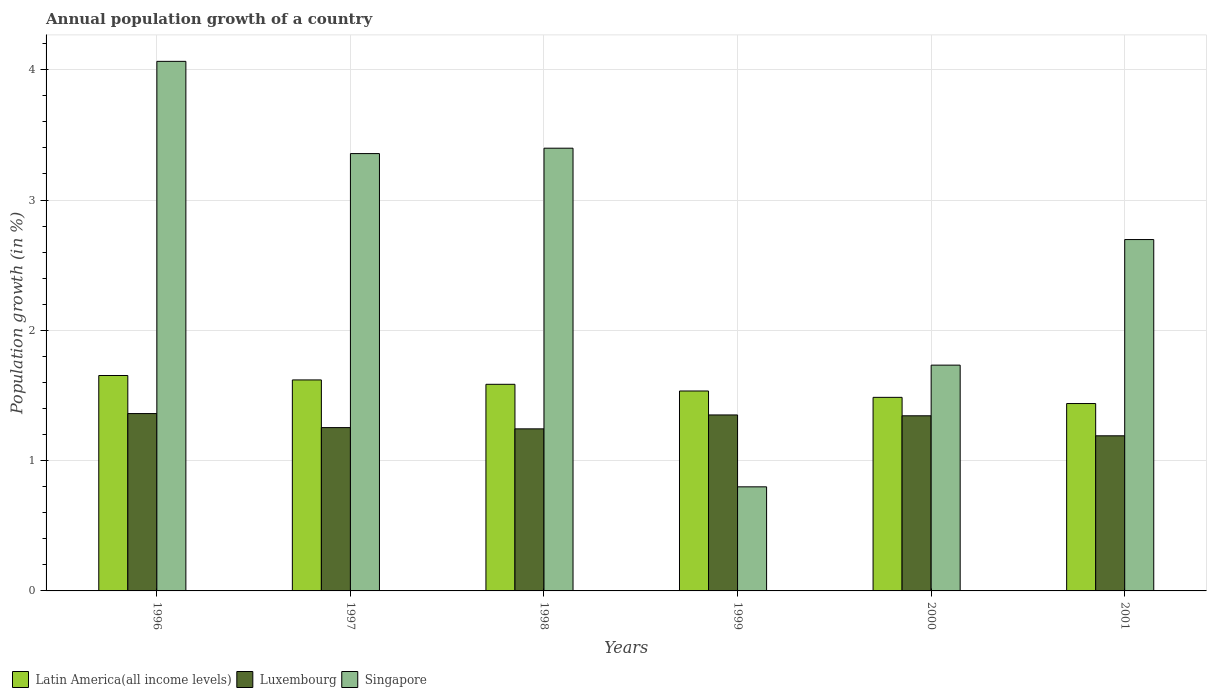How many different coloured bars are there?
Give a very brief answer. 3. How many groups of bars are there?
Give a very brief answer. 6. How many bars are there on the 5th tick from the left?
Give a very brief answer. 3. What is the label of the 5th group of bars from the left?
Ensure brevity in your answer.  2000. What is the annual population growth in Singapore in 1998?
Your answer should be compact. 3.4. Across all years, what is the maximum annual population growth in Luxembourg?
Your answer should be very brief. 1.36. Across all years, what is the minimum annual population growth in Latin America(all income levels)?
Ensure brevity in your answer.  1.44. In which year was the annual population growth in Singapore maximum?
Your response must be concise. 1996. What is the total annual population growth in Luxembourg in the graph?
Offer a very short reply. 7.74. What is the difference between the annual population growth in Latin America(all income levels) in 1997 and that in 2001?
Offer a very short reply. 0.18. What is the difference between the annual population growth in Singapore in 1997 and the annual population growth in Luxembourg in 1996?
Your response must be concise. 2. What is the average annual population growth in Singapore per year?
Make the answer very short. 2.67. In the year 1996, what is the difference between the annual population growth in Luxembourg and annual population growth in Latin America(all income levels)?
Provide a short and direct response. -0.29. In how many years, is the annual population growth in Luxembourg greater than 1.4 %?
Offer a very short reply. 0. What is the ratio of the annual population growth in Singapore in 1996 to that in 1997?
Offer a terse response. 1.21. Is the annual population growth in Latin America(all income levels) in 1998 less than that in 2000?
Keep it short and to the point. No. Is the difference between the annual population growth in Luxembourg in 1998 and 2000 greater than the difference between the annual population growth in Latin America(all income levels) in 1998 and 2000?
Your answer should be compact. No. What is the difference between the highest and the second highest annual population growth in Singapore?
Offer a very short reply. 0.67. What is the difference between the highest and the lowest annual population growth in Singapore?
Make the answer very short. 3.27. What does the 3rd bar from the left in 1998 represents?
Provide a short and direct response. Singapore. What does the 2nd bar from the right in 1999 represents?
Offer a very short reply. Luxembourg. How many bars are there?
Your response must be concise. 18. Are all the bars in the graph horizontal?
Give a very brief answer. No. Does the graph contain grids?
Provide a succinct answer. Yes. How are the legend labels stacked?
Your response must be concise. Horizontal. What is the title of the graph?
Your answer should be compact. Annual population growth of a country. Does "Palau" appear as one of the legend labels in the graph?
Your answer should be compact. No. What is the label or title of the Y-axis?
Make the answer very short. Population growth (in %). What is the Population growth (in %) of Latin America(all income levels) in 1996?
Ensure brevity in your answer.  1.65. What is the Population growth (in %) in Luxembourg in 1996?
Provide a succinct answer. 1.36. What is the Population growth (in %) of Singapore in 1996?
Your answer should be very brief. 4.06. What is the Population growth (in %) of Latin America(all income levels) in 1997?
Keep it short and to the point. 1.62. What is the Population growth (in %) of Luxembourg in 1997?
Offer a very short reply. 1.25. What is the Population growth (in %) of Singapore in 1997?
Your answer should be compact. 3.36. What is the Population growth (in %) of Latin America(all income levels) in 1998?
Give a very brief answer. 1.59. What is the Population growth (in %) of Luxembourg in 1998?
Provide a short and direct response. 1.24. What is the Population growth (in %) of Singapore in 1998?
Your response must be concise. 3.4. What is the Population growth (in %) of Latin America(all income levels) in 1999?
Your answer should be very brief. 1.53. What is the Population growth (in %) of Luxembourg in 1999?
Your response must be concise. 1.35. What is the Population growth (in %) of Singapore in 1999?
Ensure brevity in your answer.  0.8. What is the Population growth (in %) in Latin America(all income levels) in 2000?
Keep it short and to the point. 1.49. What is the Population growth (in %) of Luxembourg in 2000?
Offer a very short reply. 1.34. What is the Population growth (in %) of Singapore in 2000?
Keep it short and to the point. 1.73. What is the Population growth (in %) in Latin America(all income levels) in 2001?
Give a very brief answer. 1.44. What is the Population growth (in %) of Luxembourg in 2001?
Provide a short and direct response. 1.19. What is the Population growth (in %) of Singapore in 2001?
Your answer should be very brief. 2.7. Across all years, what is the maximum Population growth (in %) of Latin America(all income levels)?
Keep it short and to the point. 1.65. Across all years, what is the maximum Population growth (in %) of Luxembourg?
Give a very brief answer. 1.36. Across all years, what is the maximum Population growth (in %) of Singapore?
Give a very brief answer. 4.06. Across all years, what is the minimum Population growth (in %) in Latin America(all income levels)?
Give a very brief answer. 1.44. Across all years, what is the minimum Population growth (in %) of Luxembourg?
Offer a terse response. 1.19. Across all years, what is the minimum Population growth (in %) of Singapore?
Keep it short and to the point. 0.8. What is the total Population growth (in %) of Latin America(all income levels) in the graph?
Keep it short and to the point. 9.32. What is the total Population growth (in %) of Luxembourg in the graph?
Your answer should be compact. 7.74. What is the total Population growth (in %) of Singapore in the graph?
Your answer should be very brief. 16.05. What is the difference between the Population growth (in %) in Latin America(all income levels) in 1996 and that in 1997?
Offer a terse response. 0.03. What is the difference between the Population growth (in %) in Luxembourg in 1996 and that in 1997?
Provide a short and direct response. 0.11. What is the difference between the Population growth (in %) of Singapore in 1996 and that in 1997?
Ensure brevity in your answer.  0.71. What is the difference between the Population growth (in %) in Latin America(all income levels) in 1996 and that in 1998?
Your answer should be very brief. 0.07. What is the difference between the Population growth (in %) in Luxembourg in 1996 and that in 1998?
Offer a terse response. 0.12. What is the difference between the Population growth (in %) in Singapore in 1996 and that in 1998?
Offer a terse response. 0.67. What is the difference between the Population growth (in %) in Latin America(all income levels) in 1996 and that in 1999?
Make the answer very short. 0.12. What is the difference between the Population growth (in %) in Luxembourg in 1996 and that in 1999?
Provide a short and direct response. 0.01. What is the difference between the Population growth (in %) of Singapore in 1996 and that in 1999?
Provide a short and direct response. 3.27. What is the difference between the Population growth (in %) of Latin America(all income levels) in 1996 and that in 2000?
Your response must be concise. 0.17. What is the difference between the Population growth (in %) of Luxembourg in 1996 and that in 2000?
Ensure brevity in your answer.  0.02. What is the difference between the Population growth (in %) in Singapore in 1996 and that in 2000?
Your answer should be compact. 2.33. What is the difference between the Population growth (in %) of Latin America(all income levels) in 1996 and that in 2001?
Provide a succinct answer. 0.22. What is the difference between the Population growth (in %) of Luxembourg in 1996 and that in 2001?
Ensure brevity in your answer.  0.17. What is the difference between the Population growth (in %) of Singapore in 1996 and that in 2001?
Your response must be concise. 1.37. What is the difference between the Population growth (in %) in Latin America(all income levels) in 1997 and that in 1998?
Provide a short and direct response. 0.03. What is the difference between the Population growth (in %) in Luxembourg in 1997 and that in 1998?
Provide a short and direct response. 0.01. What is the difference between the Population growth (in %) of Singapore in 1997 and that in 1998?
Offer a very short reply. -0.04. What is the difference between the Population growth (in %) of Latin America(all income levels) in 1997 and that in 1999?
Ensure brevity in your answer.  0.08. What is the difference between the Population growth (in %) of Luxembourg in 1997 and that in 1999?
Keep it short and to the point. -0.1. What is the difference between the Population growth (in %) of Singapore in 1997 and that in 1999?
Provide a short and direct response. 2.56. What is the difference between the Population growth (in %) in Latin America(all income levels) in 1997 and that in 2000?
Give a very brief answer. 0.13. What is the difference between the Population growth (in %) in Luxembourg in 1997 and that in 2000?
Offer a terse response. -0.09. What is the difference between the Population growth (in %) of Singapore in 1997 and that in 2000?
Ensure brevity in your answer.  1.62. What is the difference between the Population growth (in %) in Latin America(all income levels) in 1997 and that in 2001?
Provide a short and direct response. 0.18. What is the difference between the Population growth (in %) in Luxembourg in 1997 and that in 2001?
Give a very brief answer. 0.06. What is the difference between the Population growth (in %) in Singapore in 1997 and that in 2001?
Your answer should be compact. 0.66. What is the difference between the Population growth (in %) in Latin America(all income levels) in 1998 and that in 1999?
Your response must be concise. 0.05. What is the difference between the Population growth (in %) of Luxembourg in 1998 and that in 1999?
Offer a very short reply. -0.11. What is the difference between the Population growth (in %) of Singapore in 1998 and that in 1999?
Give a very brief answer. 2.6. What is the difference between the Population growth (in %) of Latin America(all income levels) in 1998 and that in 2000?
Your response must be concise. 0.1. What is the difference between the Population growth (in %) of Luxembourg in 1998 and that in 2000?
Provide a short and direct response. -0.1. What is the difference between the Population growth (in %) in Singapore in 1998 and that in 2000?
Provide a short and direct response. 1.66. What is the difference between the Population growth (in %) in Latin America(all income levels) in 1998 and that in 2001?
Make the answer very short. 0.15. What is the difference between the Population growth (in %) of Luxembourg in 1998 and that in 2001?
Your answer should be compact. 0.05. What is the difference between the Population growth (in %) of Singapore in 1998 and that in 2001?
Offer a very short reply. 0.7. What is the difference between the Population growth (in %) in Latin America(all income levels) in 1999 and that in 2000?
Your answer should be very brief. 0.05. What is the difference between the Population growth (in %) of Luxembourg in 1999 and that in 2000?
Provide a short and direct response. 0.01. What is the difference between the Population growth (in %) in Singapore in 1999 and that in 2000?
Your answer should be compact. -0.93. What is the difference between the Population growth (in %) of Latin America(all income levels) in 1999 and that in 2001?
Keep it short and to the point. 0.1. What is the difference between the Population growth (in %) in Luxembourg in 1999 and that in 2001?
Provide a succinct answer. 0.16. What is the difference between the Population growth (in %) of Singapore in 1999 and that in 2001?
Provide a succinct answer. -1.9. What is the difference between the Population growth (in %) of Latin America(all income levels) in 2000 and that in 2001?
Your answer should be compact. 0.05. What is the difference between the Population growth (in %) of Luxembourg in 2000 and that in 2001?
Ensure brevity in your answer.  0.15. What is the difference between the Population growth (in %) of Singapore in 2000 and that in 2001?
Your answer should be very brief. -0.96. What is the difference between the Population growth (in %) of Latin America(all income levels) in 1996 and the Population growth (in %) of Luxembourg in 1997?
Give a very brief answer. 0.4. What is the difference between the Population growth (in %) in Latin America(all income levels) in 1996 and the Population growth (in %) in Singapore in 1997?
Your response must be concise. -1.7. What is the difference between the Population growth (in %) of Luxembourg in 1996 and the Population growth (in %) of Singapore in 1997?
Ensure brevity in your answer.  -2. What is the difference between the Population growth (in %) of Latin America(all income levels) in 1996 and the Population growth (in %) of Luxembourg in 1998?
Offer a very short reply. 0.41. What is the difference between the Population growth (in %) of Latin America(all income levels) in 1996 and the Population growth (in %) of Singapore in 1998?
Keep it short and to the point. -1.74. What is the difference between the Population growth (in %) in Luxembourg in 1996 and the Population growth (in %) in Singapore in 1998?
Ensure brevity in your answer.  -2.04. What is the difference between the Population growth (in %) in Latin America(all income levels) in 1996 and the Population growth (in %) in Luxembourg in 1999?
Offer a terse response. 0.3. What is the difference between the Population growth (in %) in Latin America(all income levels) in 1996 and the Population growth (in %) in Singapore in 1999?
Keep it short and to the point. 0.85. What is the difference between the Population growth (in %) in Luxembourg in 1996 and the Population growth (in %) in Singapore in 1999?
Give a very brief answer. 0.56. What is the difference between the Population growth (in %) of Latin America(all income levels) in 1996 and the Population growth (in %) of Luxembourg in 2000?
Your response must be concise. 0.31. What is the difference between the Population growth (in %) of Latin America(all income levels) in 1996 and the Population growth (in %) of Singapore in 2000?
Provide a succinct answer. -0.08. What is the difference between the Population growth (in %) in Luxembourg in 1996 and the Population growth (in %) in Singapore in 2000?
Ensure brevity in your answer.  -0.37. What is the difference between the Population growth (in %) in Latin America(all income levels) in 1996 and the Population growth (in %) in Luxembourg in 2001?
Provide a succinct answer. 0.46. What is the difference between the Population growth (in %) of Latin America(all income levels) in 1996 and the Population growth (in %) of Singapore in 2001?
Your answer should be very brief. -1.04. What is the difference between the Population growth (in %) of Luxembourg in 1996 and the Population growth (in %) of Singapore in 2001?
Provide a succinct answer. -1.34. What is the difference between the Population growth (in %) in Latin America(all income levels) in 1997 and the Population growth (in %) in Luxembourg in 1998?
Provide a succinct answer. 0.38. What is the difference between the Population growth (in %) in Latin America(all income levels) in 1997 and the Population growth (in %) in Singapore in 1998?
Your answer should be very brief. -1.78. What is the difference between the Population growth (in %) of Luxembourg in 1997 and the Population growth (in %) of Singapore in 1998?
Your response must be concise. -2.14. What is the difference between the Population growth (in %) of Latin America(all income levels) in 1997 and the Population growth (in %) of Luxembourg in 1999?
Provide a short and direct response. 0.27. What is the difference between the Population growth (in %) of Latin America(all income levels) in 1997 and the Population growth (in %) of Singapore in 1999?
Offer a terse response. 0.82. What is the difference between the Population growth (in %) of Luxembourg in 1997 and the Population growth (in %) of Singapore in 1999?
Your answer should be very brief. 0.45. What is the difference between the Population growth (in %) in Latin America(all income levels) in 1997 and the Population growth (in %) in Luxembourg in 2000?
Provide a short and direct response. 0.28. What is the difference between the Population growth (in %) in Latin America(all income levels) in 1997 and the Population growth (in %) in Singapore in 2000?
Offer a very short reply. -0.11. What is the difference between the Population growth (in %) in Luxembourg in 1997 and the Population growth (in %) in Singapore in 2000?
Offer a very short reply. -0.48. What is the difference between the Population growth (in %) of Latin America(all income levels) in 1997 and the Population growth (in %) of Luxembourg in 2001?
Make the answer very short. 0.43. What is the difference between the Population growth (in %) in Latin America(all income levels) in 1997 and the Population growth (in %) in Singapore in 2001?
Provide a succinct answer. -1.08. What is the difference between the Population growth (in %) in Luxembourg in 1997 and the Population growth (in %) in Singapore in 2001?
Your response must be concise. -1.44. What is the difference between the Population growth (in %) of Latin America(all income levels) in 1998 and the Population growth (in %) of Luxembourg in 1999?
Your answer should be very brief. 0.24. What is the difference between the Population growth (in %) in Latin America(all income levels) in 1998 and the Population growth (in %) in Singapore in 1999?
Provide a short and direct response. 0.79. What is the difference between the Population growth (in %) of Luxembourg in 1998 and the Population growth (in %) of Singapore in 1999?
Your answer should be compact. 0.45. What is the difference between the Population growth (in %) in Latin America(all income levels) in 1998 and the Population growth (in %) in Luxembourg in 2000?
Keep it short and to the point. 0.24. What is the difference between the Population growth (in %) of Latin America(all income levels) in 1998 and the Population growth (in %) of Singapore in 2000?
Make the answer very short. -0.15. What is the difference between the Population growth (in %) in Luxembourg in 1998 and the Population growth (in %) in Singapore in 2000?
Make the answer very short. -0.49. What is the difference between the Population growth (in %) of Latin America(all income levels) in 1998 and the Population growth (in %) of Luxembourg in 2001?
Give a very brief answer. 0.4. What is the difference between the Population growth (in %) in Latin America(all income levels) in 1998 and the Population growth (in %) in Singapore in 2001?
Provide a short and direct response. -1.11. What is the difference between the Population growth (in %) of Luxembourg in 1998 and the Population growth (in %) of Singapore in 2001?
Ensure brevity in your answer.  -1.45. What is the difference between the Population growth (in %) of Latin America(all income levels) in 1999 and the Population growth (in %) of Luxembourg in 2000?
Provide a short and direct response. 0.19. What is the difference between the Population growth (in %) in Latin America(all income levels) in 1999 and the Population growth (in %) in Singapore in 2000?
Offer a terse response. -0.2. What is the difference between the Population growth (in %) in Luxembourg in 1999 and the Population growth (in %) in Singapore in 2000?
Ensure brevity in your answer.  -0.38. What is the difference between the Population growth (in %) in Latin America(all income levels) in 1999 and the Population growth (in %) in Luxembourg in 2001?
Keep it short and to the point. 0.34. What is the difference between the Population growth (in %) in Latin America(all income levels) in 1999 and the Population growth (in %) in Singapore in 2001?
Offer a very short reply. -1.16. What is the difference between the Population growth (in %) of Luxembourg in 1999 and the Population growth (in %) of Singapore in 2001?
Your answer should be compact. -1.35. What is the difference between the Population growth (in %) of Latin America(all income levels) in 2000 and the Population growth (in %) of Luxembourg in 2001?
Provide a short and direct response. 0.3. What is the difference between the Population growth (in %) in Latin America(all income levels) in 2000 and the Population growth (in %) in Singapore in 2001?
Offer a terse response. -1.21. What is the difference between the Population growth (in %) of Luxembourg in 2000 and the Population growth (in %) of Singapore in 2001?
Offer a terse response. -1.35. What is the average Population growth (in %) of Latin America(all income levels) per year?
Keep it short and to the point. 1.55. What is the average Population growth (in %) of Luxembourg per year?
Your answer should be compact. 1.29. What is the average Population growth (in %) in Singapore per year?
Provide a short and direct response. 2.67. In the year 1996, what is the difference between the Population growth (in %) in Latin America(all income levels) and Population growth (in %) in Luxembourg?
Give a very brief answer. 0.29. In the year 1996, what is the difference between the Population growth (in %) of Latin America(all income levels) and Population growth (in %) of Singapore?
Keep it short and to the point. -2.41. In the year 1996, what is the difference between the Population growth (in %) of Luxembourg and Population growth (in %) of Singapore?
Your answer should be very brief. -2.7. In the year 1997, what is the difference between the Population growth (in %) in Latin America(all income levels) and Population growth (in %) in Luxembourg?
Your answer should be very brief. 0.37. In the year 1997, what is the difference between the Population growth (in %) of Latin America(all income levels) and Population growth (in %) of Singapore?
Your response must be concise. -1.74. In the year 1997, what is the difference between the Population growth (in %) in Luxembourg and Population growth (in %) in Singapore?
Keep it short and to the point. -2.1. In the year 1998, what is the difference between the Population growth (in %) of Latin America(all income levels) and Population growth (in %) of Luxembourg?
Your response must be concise. 0.34. In the year 1998, what is the difference between the Population growth (in %) of Latin America(all income levels) and Population growth (in %) of Singapore?
Your answer should be very brief. -1.81. In the year 1998, what is the difference between the Population growth (in %) in Luxembourg and Population growth (in %) in Singapore?
Offer a very short reply. -2.15. In the year 1999, what is the difference between the Population growth (in %) of Latin America(all income levels) and Population growth (in %) of Luxembourg?
Provide a short and direct response. 0.18. In the year 1999, what is the difference between the Population growth (in %) in Latin America(all income levels) and Population growth (in %) in Singapore?
Make the answer very short. 0.74. In the year 1999, what is the difference between the Population growth (in %) of Luxembourg and Population growth (in %) of Singapore?
Your response must be concise. 0.55. In the year 2000, what is the difference between the Population growth (in %) of Latin America(all income levels) and Population growth (in %) of Luxembourg?
Give a very brief answer. 0.14. In the year 2000, what is the difference between the Population growth (in %) in Latin America(all income levels) and Population growth (in %) in Singapore?
Offer a terse response. -0.25. In the year 2000, what is the difference between the Population growth (in %) in Luxembourg and Population growth (in %) in Singapore?
Your answer should be compact. -0.39. In the year 2001, what is the difference between the Population growth (in %) in Latin America(all income levels) and Population growth (in %) in Luxembourg?
Your answer should be very brief. 0.25. In the year 2001, what is the difference between the Population growth (in %) in Latin America(all income levels) and Population growth (in %) in Singapore?
Your answer should be compact. -1.26. In the year 2001, what is the difference between the Population growth (in %) in Luxembourg and Population growth (in %) in Singapore?
Offer a terse response. -1.51. What is the ratio of the Population growth (in %) in Latin America(all income levels) in 1996 to that in 1997?
Give a very brief answer. 1.02. What is the ratio of the Population growth (in %) of Luxembourg in 1996 to that in 1997?
Ensure brevity in your answer.  1.09. What is the ratio of the Population growth (in %) in Singapore in 1996 to that in 1997?
Offer a very short reply. 1.21. What is the ratio of the Population growth (in %) of Latin America(all income levels) in 1996 to that in 1998?
Provide a succinct answer. 1.04. What is the ratio of the Population growth (in %) of Luxembourg in 1996 to that in 1998?
Offer a very short reply. 1.09. What is the ratio of the Population growth (in %) in Singapore in 1996 to that in 1998?
Your answer should be compact. 1.2. What is the ratio of the Population growth (in %) in Latin America(all income levels) in 1996 to that in 1999?
Keep it short and to the point. 1.08. What is the ratio of the Population growth (in %) in Singapore in 1996 to that in 1999?
Provide a succinct answer. 5.09. What is the ratio of the Population growth (in %) of Latin America(all income levels) in 1996 to that in 2000?
Your response must be concise. 1.11. What is the ratio of the Population growth (in %) in Luxembourg in 1996 to that in 2000?
Give a very brief answer. 1.01. What is the ratio of the Population growth (in %) of Singapore in 1996 to that in 2000?
Your answer should be compact. 2.35. What is the ratio of the Population growth (in %) of Latin America(all income levels) in 1996 to that in 2001?
Your response must be concise. 1.15. What is the ratio of the Population growth (in %) of Luxembourg in 1996 to that in 2001?
Your answer should be very brief. 1.14. What is the ratio of the Population growth (in %) in Singapore in 1996 to that in 2001?
Your answer should be very brief. 1.51. What is the ratio of the Population growth (in %) in Latin America(all income levels) in 1997 to that in 1998?
Give a very brief answer. 1.02. What is the ratio of the Population growth (in %) in Luxembourg in 1997 to that in 1998?
Provide a succinct answer. 1.01. What is the ratio of the Population growth (in %) in Singapore in 1997 to that in 1998?
Ensure brevity in your answer.  0.99. What is the ratio of the Population growth (in %) in Latin America(all income levels) in 1997 to that in 1999?
Your answer should be compact. 1.06. What is the ratio of the Population growth (in %) in Luxembourg in 1997 to that in 1999?
Your response must be concise. 0.93. What is the ratio of the Population growth (in %) in Singapore in 1997 to that in 1999?
Make the answer very short. 4.2. What is the ratio of the Population growth (in %) in Latin America(all income levels) in 1997 to that in 2000?
Offer a very short reply. 1.09. What is the ratio of the Population growth (in %) of Luxembourg in 1997 to that in 2000?
Keep it short and to the point. 0.93. What is the ratio of the Population growth (in %) of Singapore in 1997 to that in 2000?
Offer a terse response. 1.94. What is the ratio of the Population growth (in %) in Latin America(all income levels) in 1997 to that in 2001?
Offer a very short reply. 1.13. What is the ratio of the Population growth (in %) of Luxembourg in 1997 to that in 2001?
Provide a short and direct response. 1.05. What is the ratio of the Population growth (in %) of Singapore in 1997 to that in 2001?
Ensure brevity in your answer.  1.24. What is the ratio of the Population growth (in %) in Latin America(all income levels) in 1998 to that in 1999?
Provide a succinct answer. 1.03. What is the ratio of the Population growth (in %) in Luxembourg in 1998 to that in 1999?
Your answer should be compact. 0.92. What is the ratio of the Population growth (in %) in Singapore in 1998 to that in 1999?
Provide a short and direct response. 4.25. What is the ratio of the Population growth (in %) in Latin America(all income levels) in 1998 to that in 2000?
Offer a very short reply. 1.07. What is the ratio of the Population growth (in %) of Luxembourg in 1998 to that in 2000?
Keep it short and to the point. 0.93. What is the ratio of the Population growth (in %) of Singapore in 1998 to that in 2000?
Offer a very short reply. 1.96. What is the ratio of the Population growth (in %) of Latin America(all income levels) in 1998 to that in 2001?
Give a very brief answer. 1.1. What is the ratio of the Population growth (in %) in Luxembourg in 1998 to that in 2001?
Provide a succinct answer. 1.04. What is the ratio of the Population growth (in %) in Singapore in 1998 to that in 2001?
Offer a terse response. 1.26. What is the ratio of the Population growth (in %) in Latin America(all income levels) in 1999 to that in 2000?
Give a very brief answer. 1.03. What is the ratio of the Population growth (in %) in Singapore in 1999 to that in 2000?
Make the answer very short. 0.46. What is the ratio of the Population growth (in %) of Latin America(all income levels) in 1999 to that in 2001?
Provide a short and direct response. 1.07. What is the ratio of the Population growth (in %) of Luxembourg in 1999 to that in 2001?
Your answer should be very brief. 1.13. What is the ratio of the Population growth (in %) of Singapore in 1999 to that in 2001?
Keep it short and to the point. 0.3. What is the ratio of the Population growth (in %) of Latin America(all income levels) in 2000 to that in 2001?
Your answer should be compact. 1.03. What is the ratio of the Population growth (in %) of Luxembourg in 2000 to that in 2001?
Your answer should be compact. 1.13. What is the ratio of the Population growth (in %) in Singapore in 2000 to that in 2001?
Your response must be concise. 0.64. What is the difference between the highest and the second highest Population growth (in %) in Latin America(all income levels)?
Keep it short and to the point. 0.03. What is the difference between the highest and the second highest Population growth (in %) in Luxembourg?
Give a very brief answer. 0.01. What is the difference between the highest and the second highest Population growth (in %) of Singapore?
Provide a short and direct response. 0.67. What is the difference between the highest and the lowest Population growth (in %) of Latin America(all income levels)?
Ensure brevity in your answer.  0.22. What is the difference between the highest and the lowest Population growth (in %) in Luxembourg?
Offer a very short reply. 0.17. What is the difference between the highest and the lowest Population growth (in %) of Singapore?
Your answer should be very brief. 3.27. 